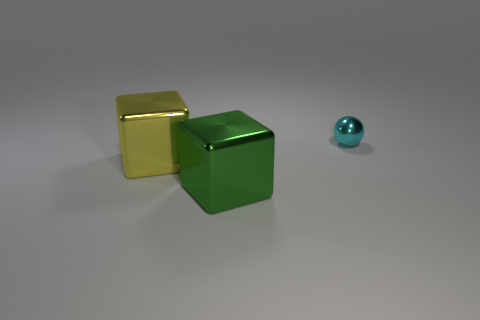How does the lighting in the image affect the perception of the objects? The lighting in the image casts soft shadows and highlights the reflective qualities of the objects, giving them a three-dimensional quality and enhancing their textures. It helps to distinguish the shape and depth of each object while also emphasizing the differences in color and shine between them. 